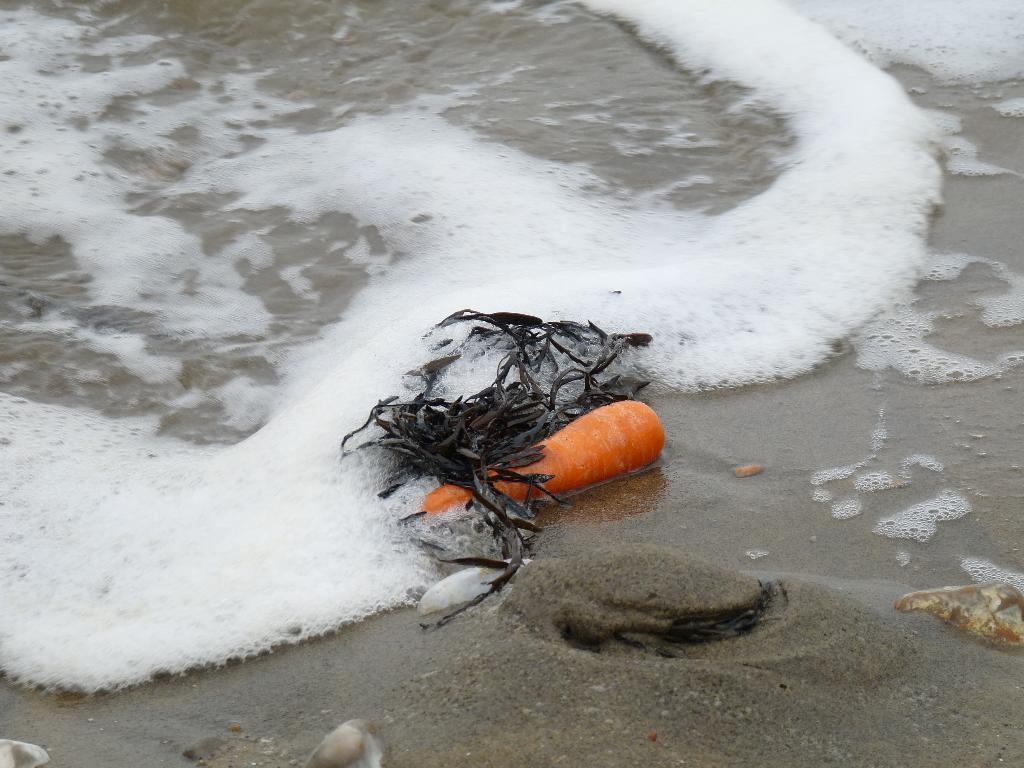Could you give a brief overview of what you see in this image? In this image I can see the carrot, shell and dried leaves on the sand. To the side I can see the foam and water. 